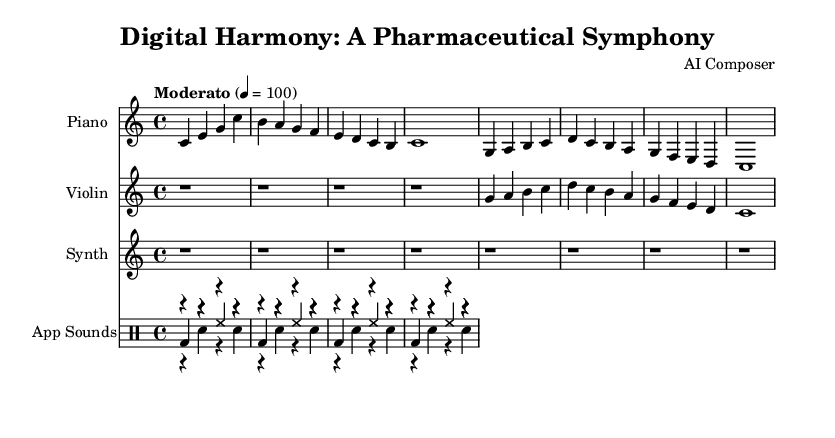What is the key signature of this music? The key signature is indicated at the beginning of the staff. It shows C major, which has no sharps or flats.
Answer: C major What is the time signature? The time signature is shown at the beginning as well, indicating how many beats are in each measure. It shows 4/4, meaning there are four beats per measure.
Answer: 4/4 What is the tempo marking of the piece? The tempo marking is specified in the score and indicates the speed of the music. Here, it states "Moderato" with a metronome marking of quarter note equals 100 beats per minute.
Answer: Moderato, 100 How many measures are there in the piano part? By counting the vertical lines (bar lines) in the piano section, there are eight measures present in total.
Answer: 8 What type of sounds are used for app notifications? The score indicates specific sound types for app notifications. The sounds indicated here are pill reminder, heart rate alert, and water intake notification.
Answer: Pill reminder, heart rate alert, water intake notification Which instrument has rests in the first four measures? The violin part has only rests in the first four measures, indicated by the "r" symbol, and does not play any notes during that time.
Answer: Violin What is the last note played by the synthesizer? The synthesizer part shows only rests and does not articulate any notes throughout the score, thus the last note is not recorded.
Answer: None 